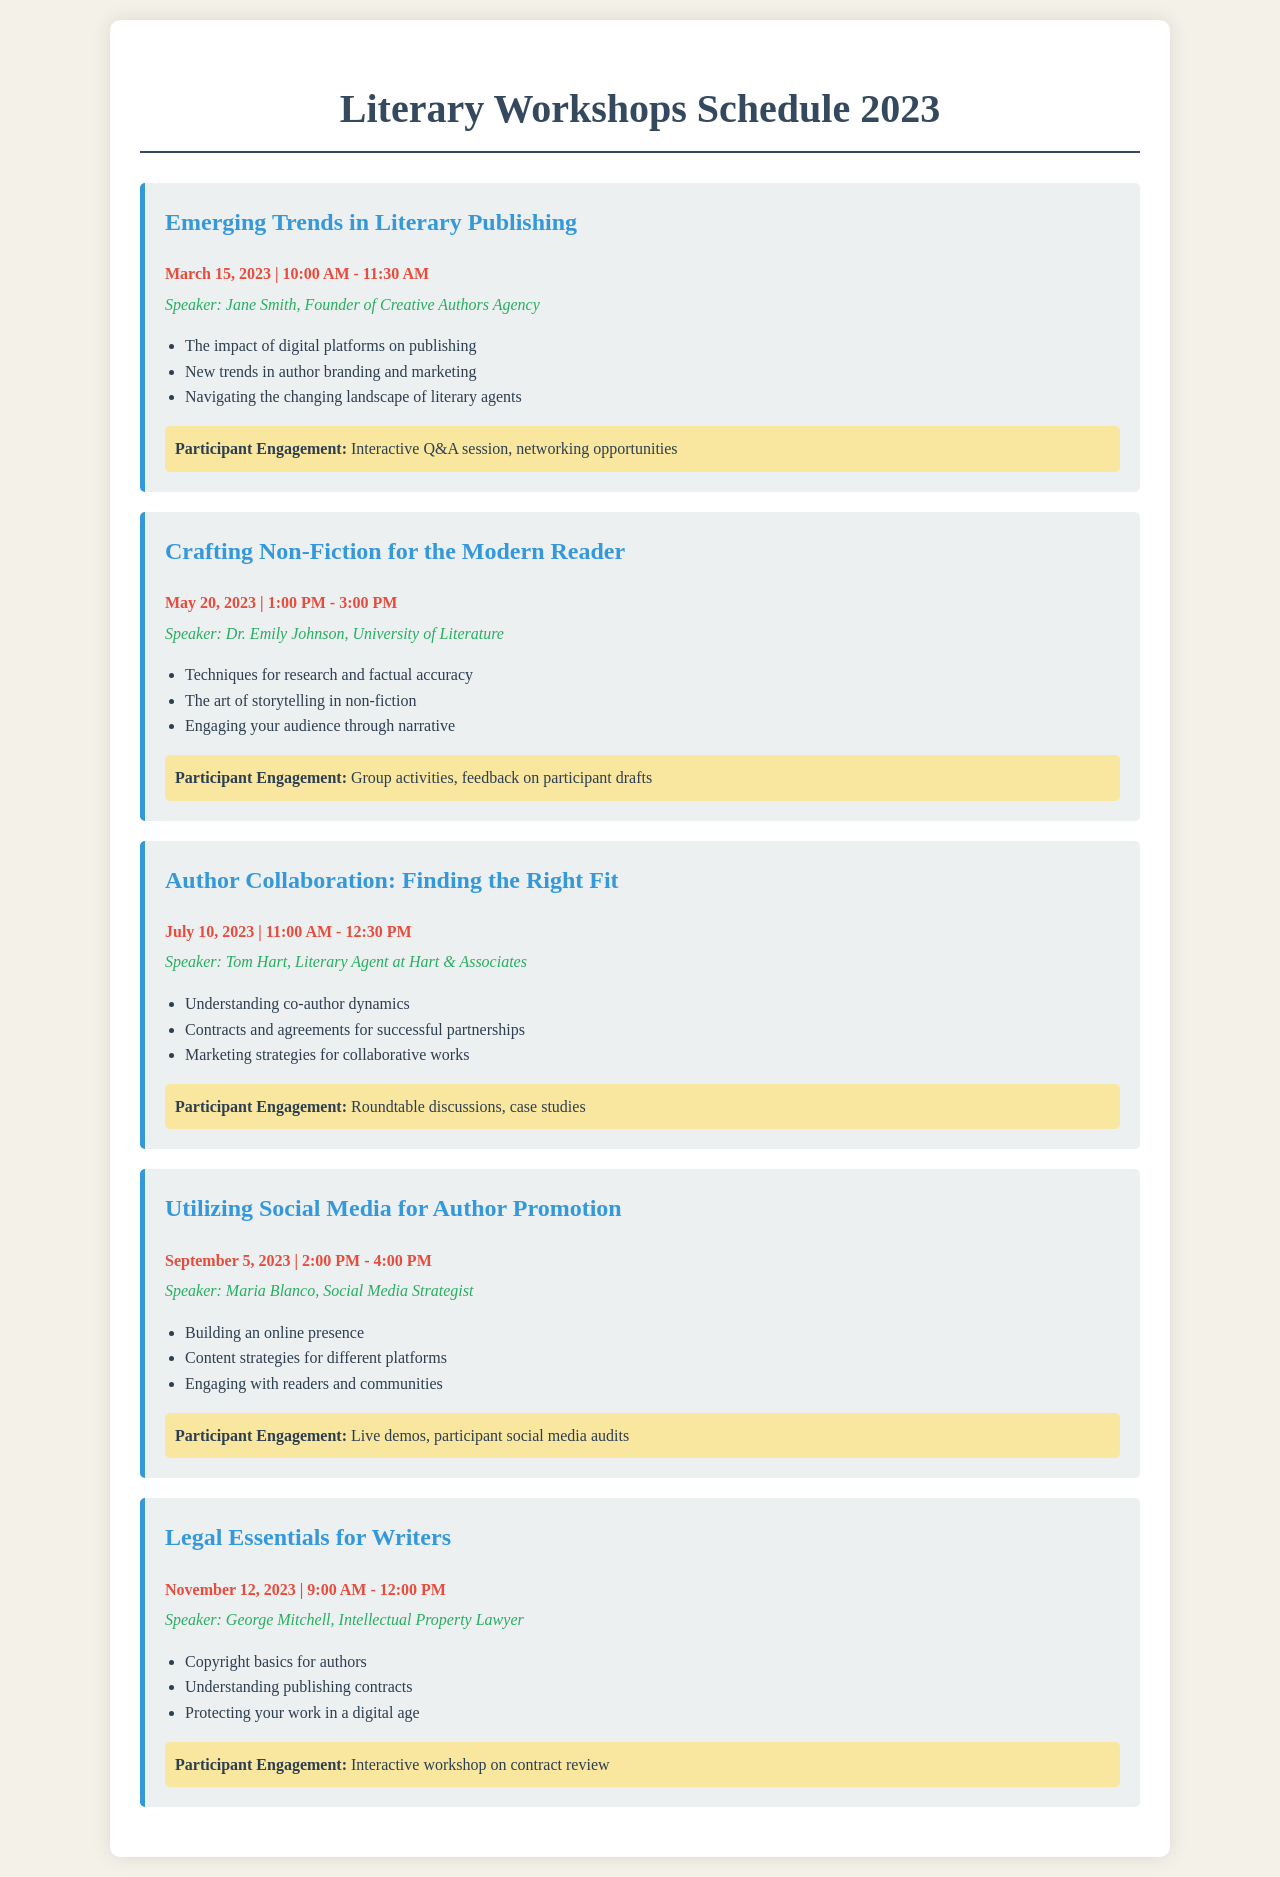What is the date of the workshop on "Emerging Trends in Literary Publishing"? The date for this workshop can be found in the schedule section, which shows March 15, 2023.
Answer: March 15, 2023 Who is the speaker for "Legal Essentials for Writers"? The speaker's name is listed under the workshop title for this session, which is George Mitchell.
Answer: George Mitchell How long is the "Crafting Non-Fiction for the Modern Reader" workshop? The duration is indicated by the time mentioned, which is from 1:00 PM to 3:00 PM, totaling 2 hours.
Answer: 2 hours What are the engagement activities mentioned for the "Utilizing Social Media for Author Promotion" session? The engagement elements are listed in the workshop section, which includes live demos and participant social media audits.
Answer: Live demos, participant social media audits Which month does the "Author Collaboration: Finding the Right Fit" workshop take place? The month is noted in the schedule next to the workshop title, which shows that it occurs in July.
Answer: July What are the key topics covered in the workshop led by Dr. Emily Johnson? The topics can be found in the bullet points under her workshop title, focusing on techniques for research, storytelling, and audience engagement.
Answer: Techniques for research and factual accuracy, The art of storytelling in non-fiction, Engaging your audience through narrative What is the theme of the May 20 workshop? The theme is located in the workshop title section, which states it is about "Crafting Non-Fiction for the Modern Reader."
Answer: Crafting Non-Fiction for the Modern Reader What is the time slot for the "Emerging Trends in Literary Publishing" workshop? The time is detailed right after the date in the respective workshop section, specified as 10:00 AM - 11:30 AM.
Answer: 10:00 AM - 11:30 AM 